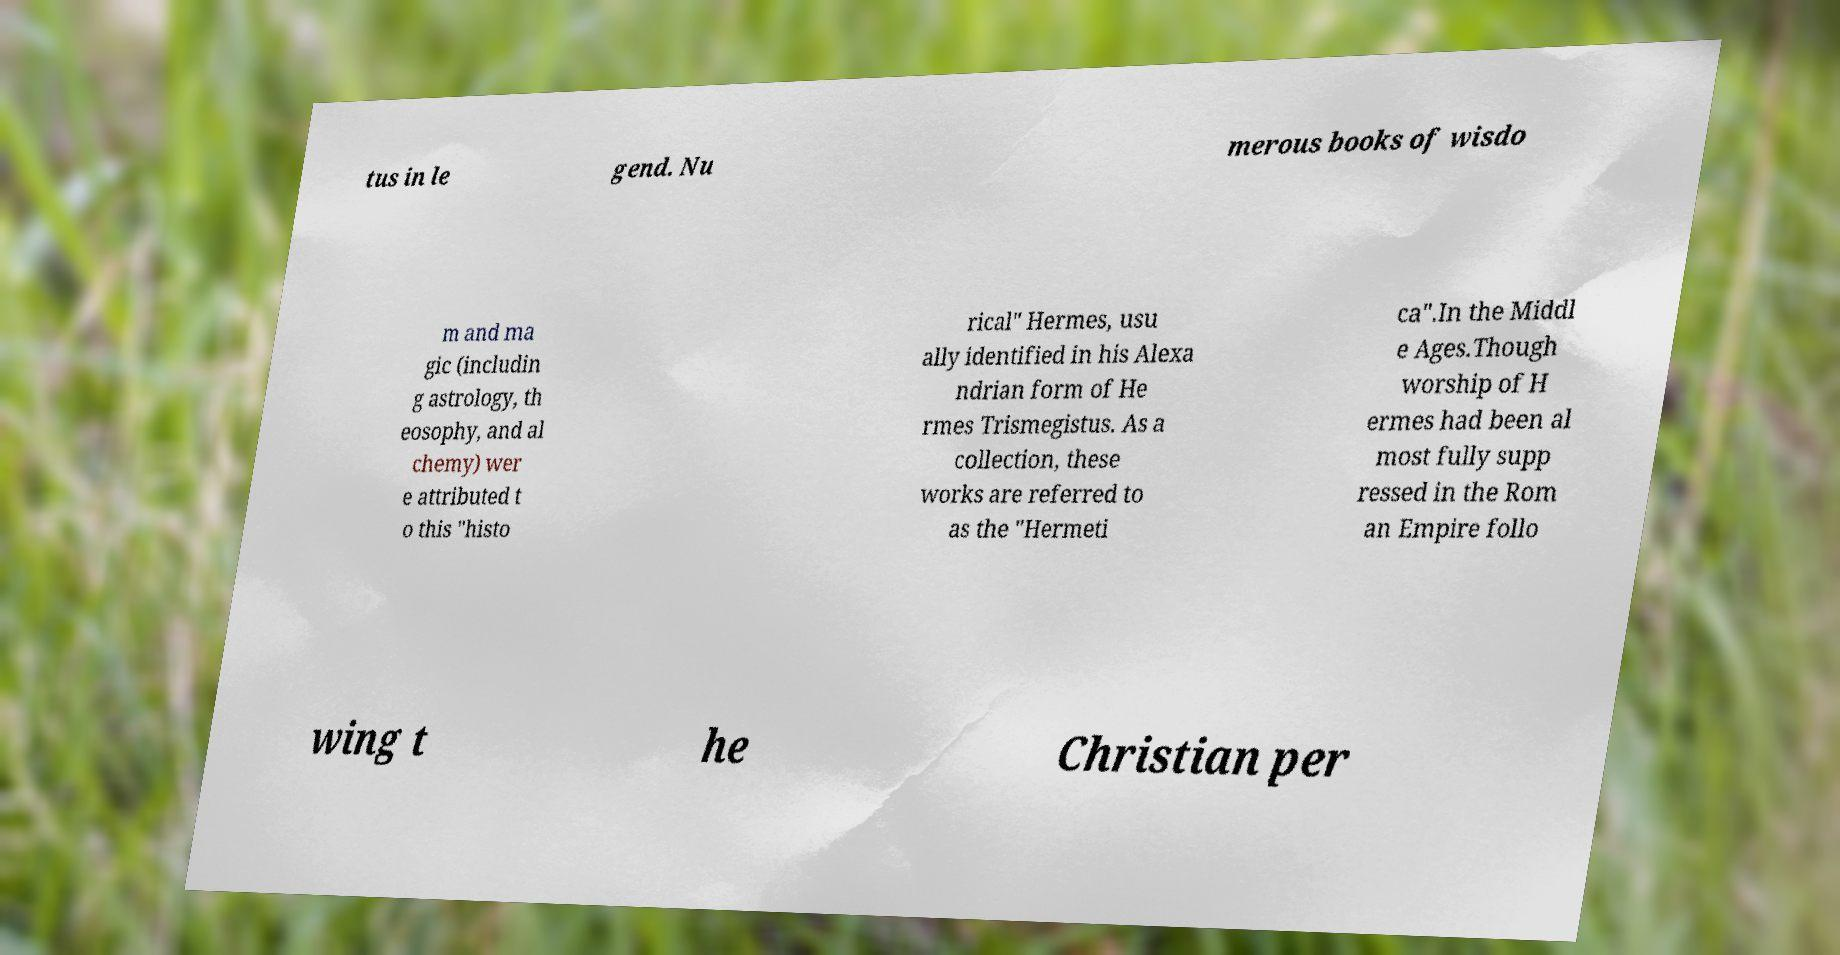Can you accurately transcribe the text from the provided image for me? tus in le gend. Nu merous books of wisdo m and ma gic (includin g astrology, th eosophy, and al chemy) wer e attributed t o this "histo rical" Hermes, usu ally identified in his Alexa ndrian form of He rmes Trismegistus. As a collection, these works are referred to as the "Hermeti ca".In the Middl e Ages.Though worship of H ermes had been al most fully supp ressed in the Rom an Empire follo wing t he Christian per 